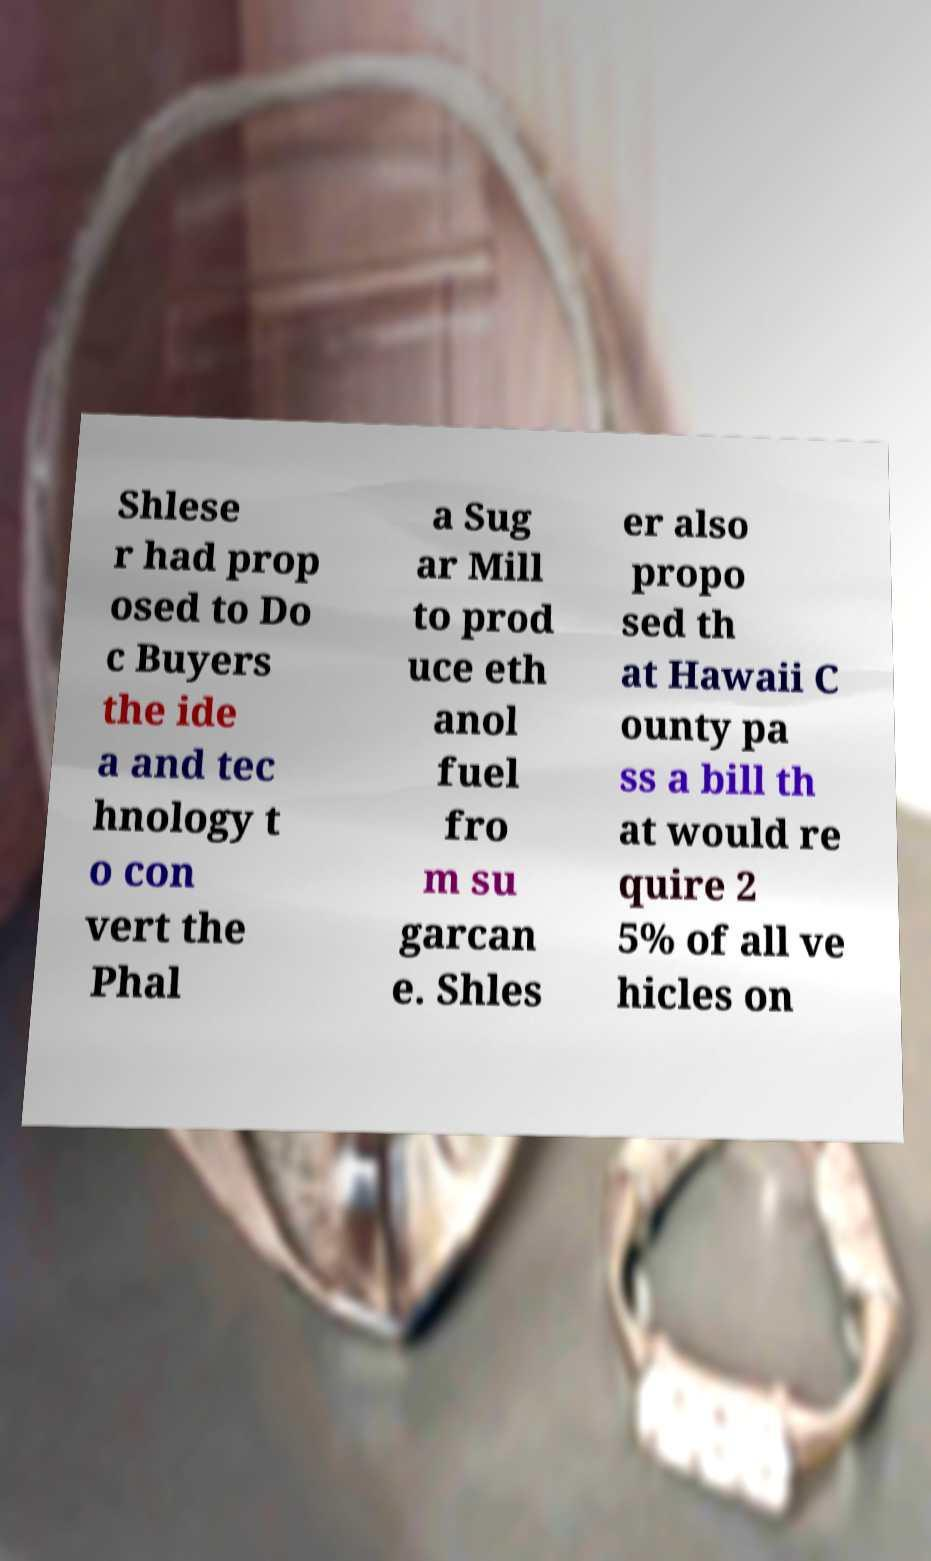Please identify and transcribe the text found in this image. Shlese r had prop osed to Do c Buyers the ide a and tec hnology t o con vert the Phal a Sug ar Mill to prod uce eth anol fuel fro m su garcan e. Shles er also propo sed th at Hawaii C ounty pa ss a bill th at would re quire 2 5% of all ve hicles on 